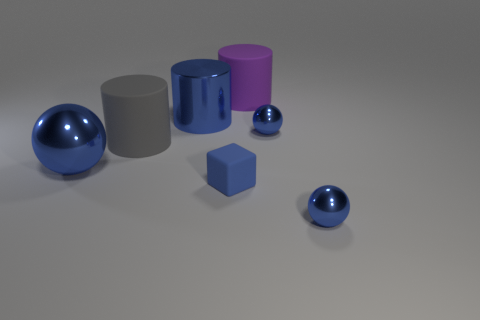Are there the same number of tiny cubes that are to the right of the large purple matte cylinder and big red cubes?
Keep it short and to the point. Yes. Is the tiny matte cube the same color as the big metallic cylinder?
Offer a very short reply. Yes. What is the size of the thing that is both in front of the big ball and on the right side of the large purple cylinder?
Offer a terse response. Small. What is the color of the cylinder that is made of the same material as the large purple thing?
Keep it short and to the point. Gray. How many small balls are made of the same material as the tiny blue block?
Offer a very short reply. 0. Are there an equal number of tiny metal balls to the left of the blue cube and tiny blocks that are on the left side of the big blue cylinder?
Provide a short and direct response. Yes. Do the purple thing and the gray rubber thing that is left of the large blue shiny cylinder have the same shape?
Offer a very short reply. Yes. There is a cylinder that is the same color as the tiny rubber block; what is it made of?
Offer a very short reply. Metal. Are there any other things that are the same shape as the tiny blue matte object?
Offer a very short reply. No. Does the gray thing have the same material as the small blue ball behind the blue block?
Make the answer very short. No. 